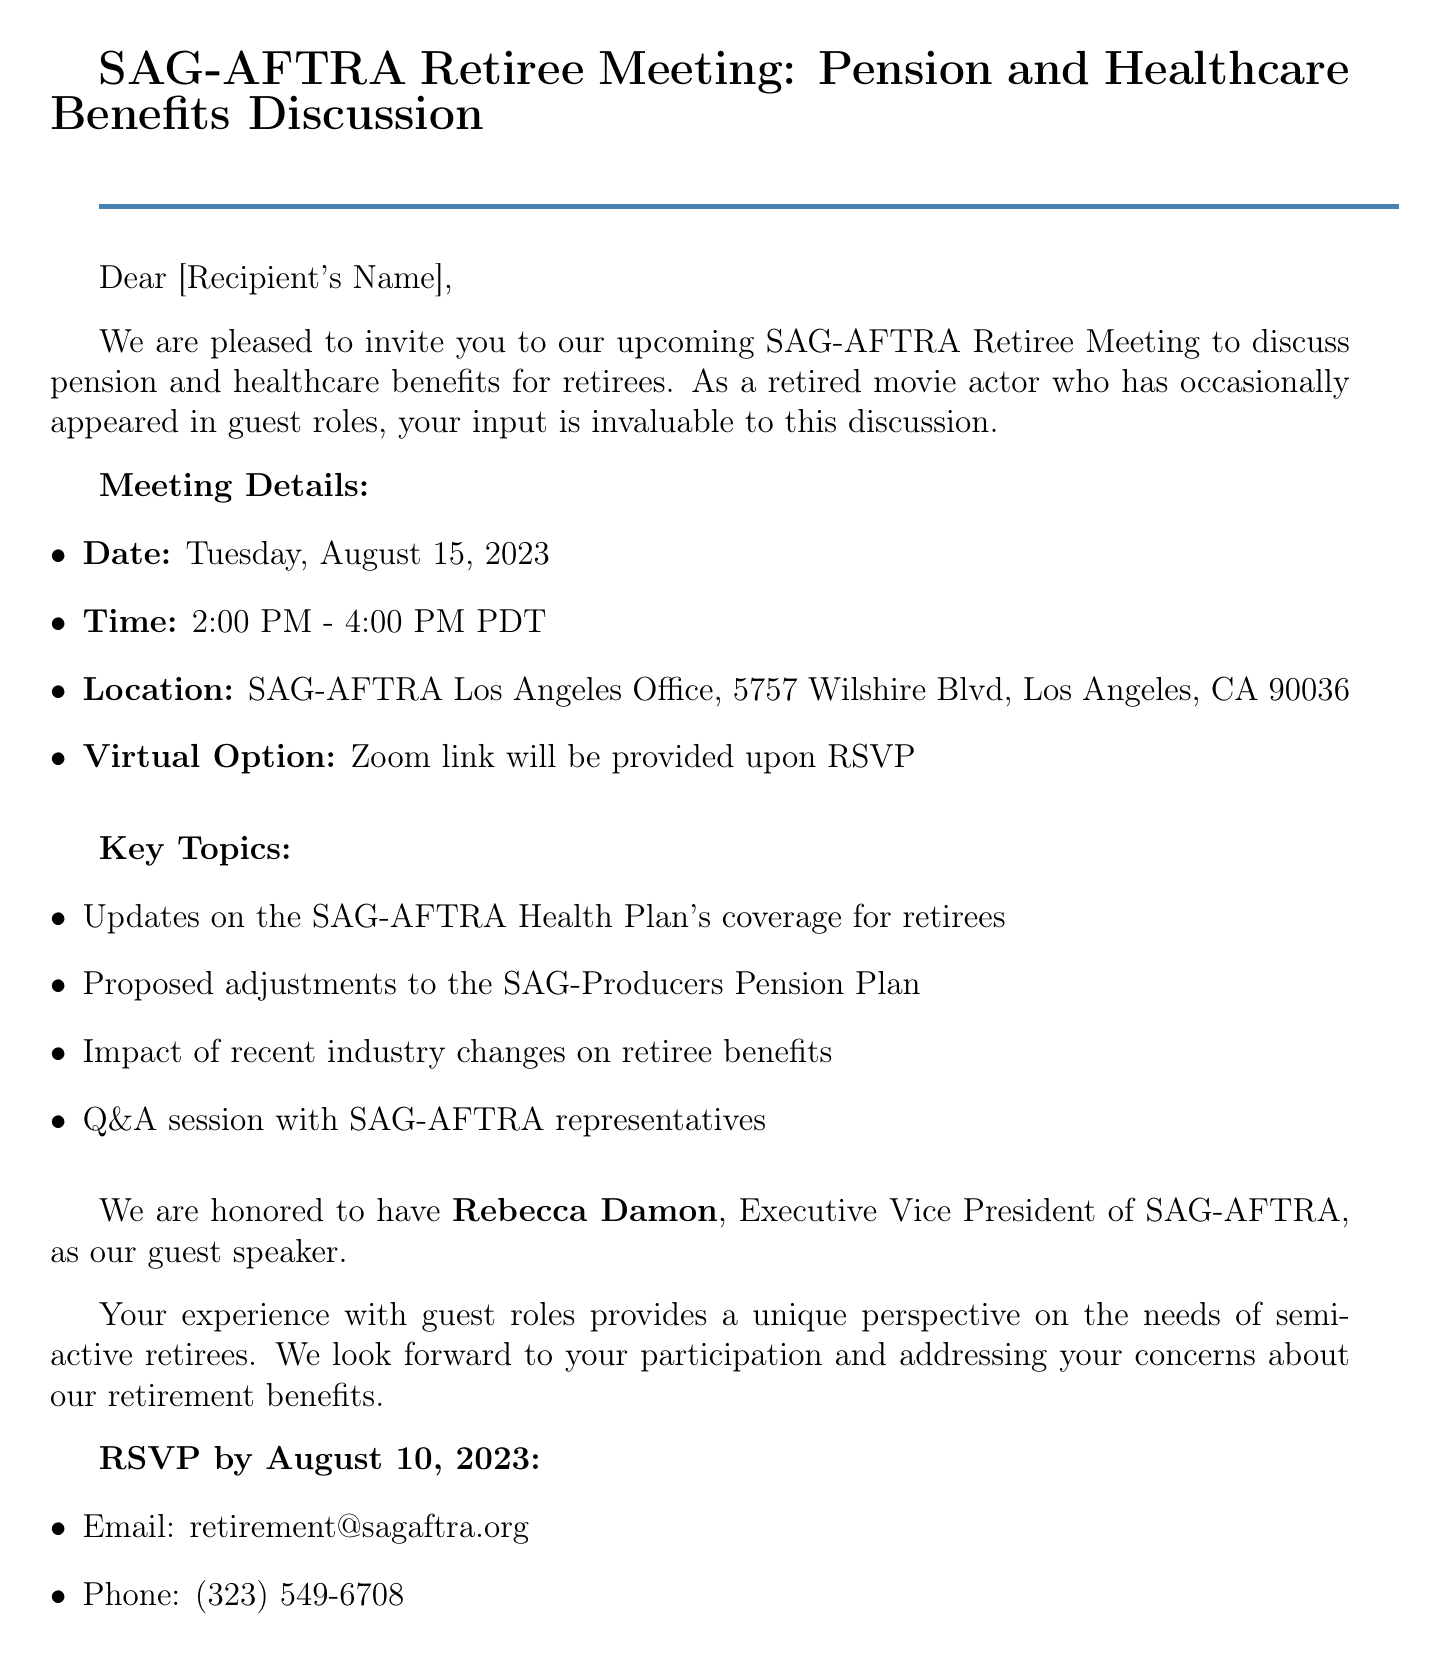What is the date of the meeting? The date of the meeting is mentioned explicitly in the document.
Answer: Tuesday, August 15, 2023 What time does the meeting start? The start time of the meeting is clearly stated in the document.
Answer: 2:00 PM Where is the meeting located? The location of the meeting is provided in the document.
Answer: SAG-AFTRA Los Angeles Office, 5757 Wilshire Blvd, Los Angeles, CA 90036 Who is the guest speaker? The document specifies the name of the guest speaker for the meeting.
Answer: Rebecca Damon What is the deadline for RSVP? The deadline for RSVP is outlined in the document.
Answer: August 10, 2023 What will be discussed in the Q&A session? The document states that the Q&A session will involve SAG-AFTRA representatives.
Answer: SAG-AFTRA representatives Who wrote the email? The document provides the name of the person who signed the email.
Answer: David White What is the contact email for RSVPs? The document includes specific contact information for RSVPs.
Answer: retirement@sagaftra.org What is one of the key topics of the meeting? The document lists key topics to be discussed in the meeting.
Answer: Updates on the SAG-AFTRA Health Plan's coverage for retirees 